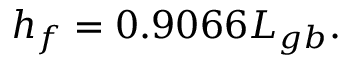<formula> <loc_0><loc_0><loc_500><loc_500>h _ { f } = 0 . 9 0 6 6 L _ { g b } .</formula> 